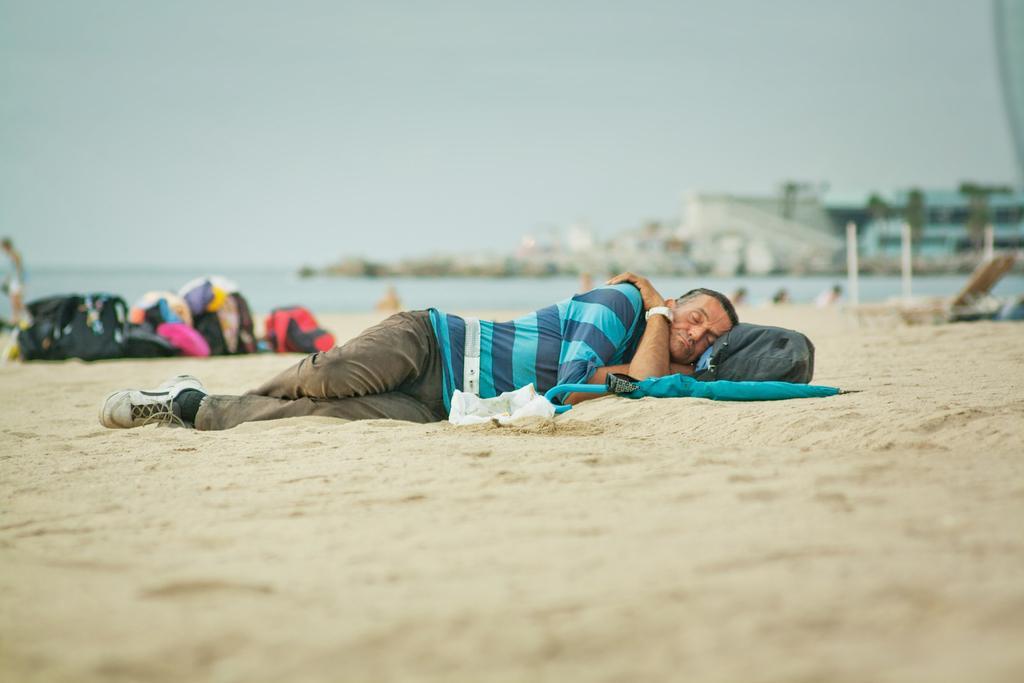Describe this image in one or two sentences. In this picture I can see a man laying on the ground and I can see a bag and an umbrella on the ground and I can see few bags on the left side and buildings, I can see water and human standing on the left side of the picture and a cloudy sky. 